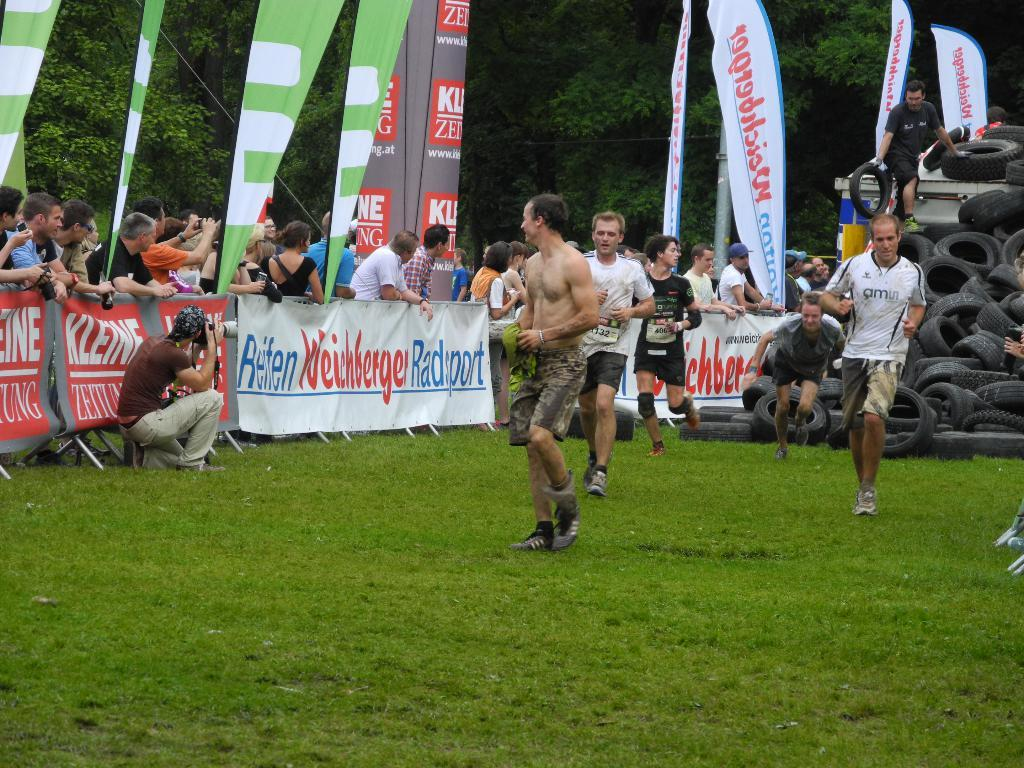<image>
Write a terse but informative summary of the picture. Some men playing sports; the word Kleine is seen on the advertising banner. 